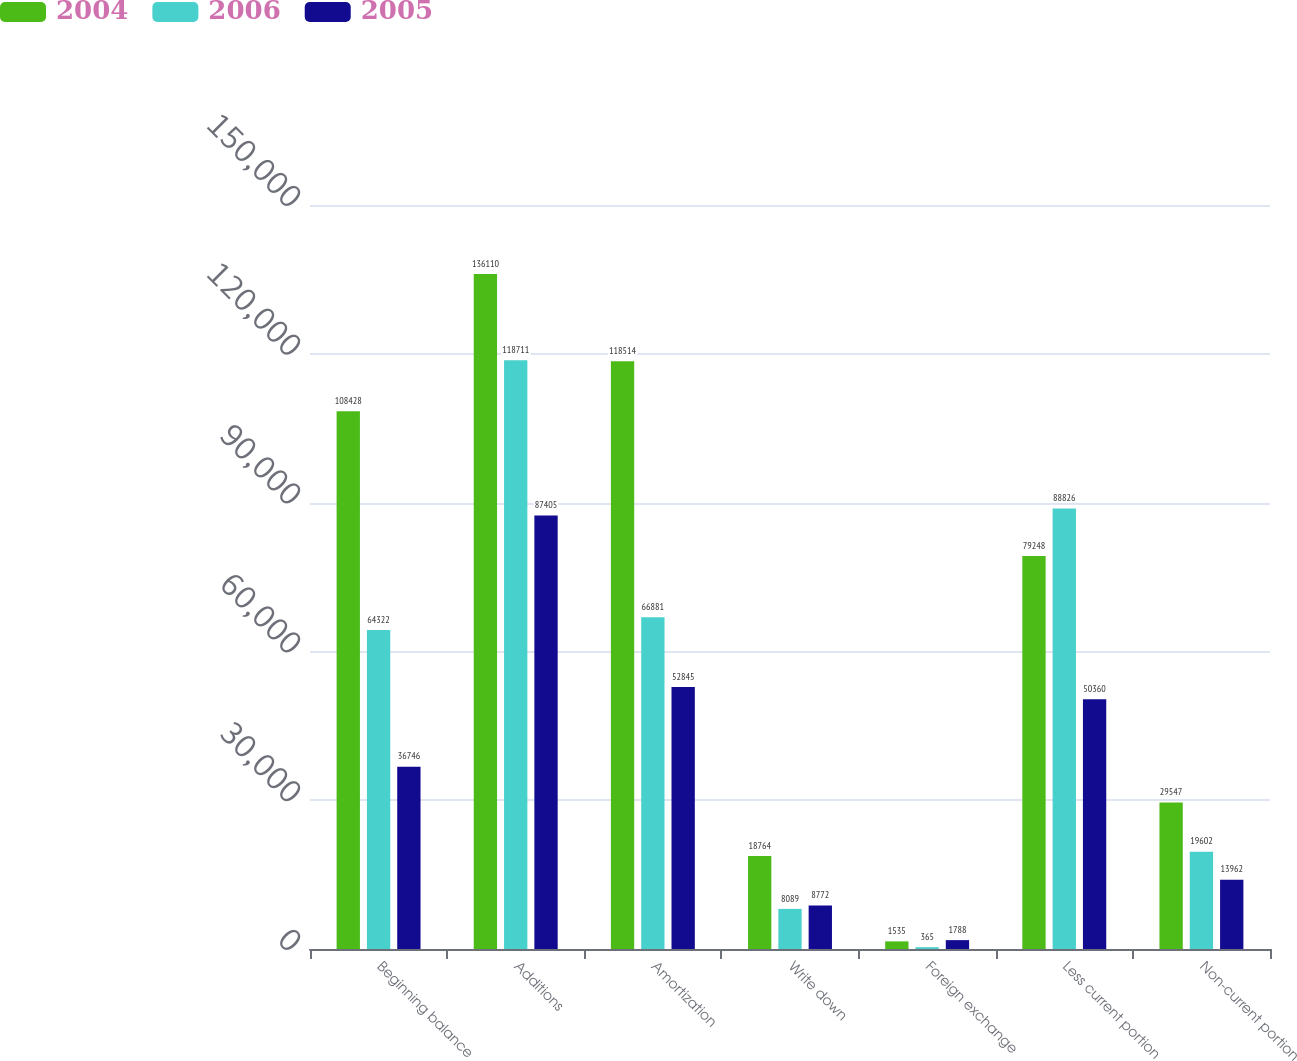Convert chart. <chart><loc_0><loc_0><loc_500><loc_500><stacked_bar_chart><ecel><fcel>Beginning balance<fcel>Additions<fcel>Amortization<fcel>Write down<fcel>Foreign exchange<fcel>Less current portion<fcel>Non-current portion<nl><fcel>2004<fcel>108428<fcel>136110<fcel>118514<fcel>18764<fcel>1535<fcel>79248<fcel>29547<nl><fcel>2006<fcel>64322<fcel>118711<fcel>66881<fcel>8089<fcel>365<fcel>88826<fcel>19602<nl><fcel>2005<fcel>36746<fcel>87405<fcel>52845<fcel>8772<fcel>1788<fcel>50360<fcel>13962<nl></chart> 